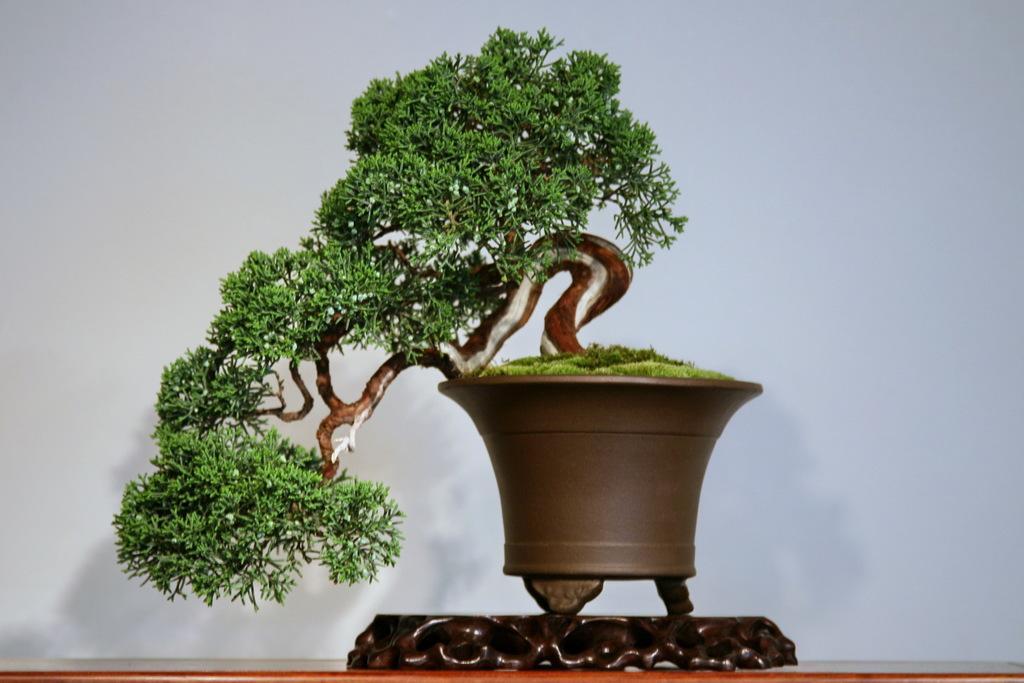Describe this image in one or two sentences. In this picture we can see a plant in the front, it looks like a wall in the background. 